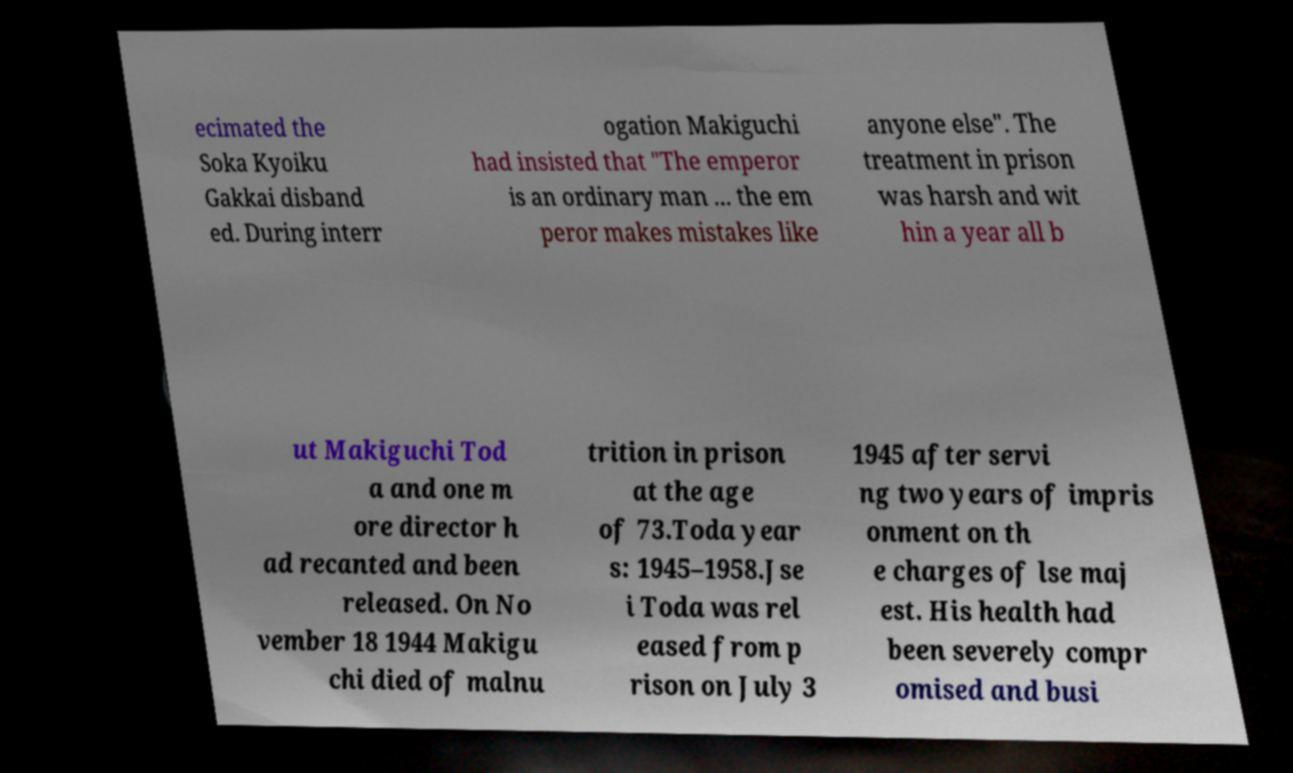Please identify and transcribe the text found in this image. ecimated the Soka Kyoiku Gakkai disband ed. During interr ogation Makiguchi had insisted that "The emperor is an ordinary man ... the em peror makes mistakes like anyone else". The treatment in prison was harsh and wit hin a year all b ut Makiguchi Tod a and one m ore director h ad recanted and been released. On No vember 18 1944 Makigu chi died of malnu trition in prison at the age of 73.Toda year s: 1945–1958.Jse i Toda was rel eased from p rison on July 3 1945 after servi ng two years of impris onment on th e charges of lse maj est. His health had been severely compr omised and busi 